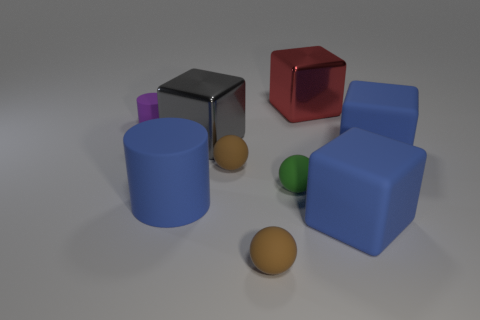What color is the other rubber object that is the same shape as the small purple matte object?
Offer a very short reply. Blue. There is a tiny green thing that is right of the gray shiny cube; is there a small brown matte ball behind it?
Your response must be concise. Yes. How big is the green ball?
Offer a terse response. Small. There is a matte object that is both in front of the purple object and on the left side of the gray metallic block; what shape is it?
Provide a succinct answer. Cylinder. How many purple things are either large matte balls or small matte cylinders?
Provide a short and direct response. 1. Does the rubber cylinder in front of the tiny cylinder have the same size as the rubber object behind the big gray block?
Provide a short and direct response. No. What number of things are balls or large blocks?
Offer a very short reply. 7. Are there any big blue things of the same shape as the small purple matte thing?
Give a very brief answer. Yes. Are there fewer blue matte cubes than cyan matte cylinders?
Your answer should be very brief. No. Is the shape of the purple matte thing the same as the gray object?
Ensure brevity in your answer.  No. 